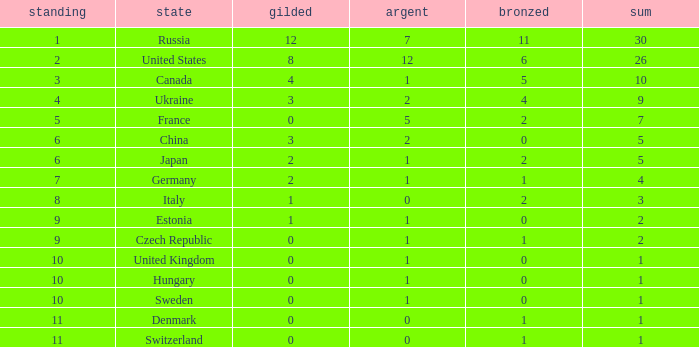How many silvers have a Nation of hungary, and a Rank larger than 10? 0.0. 